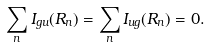<formula> <loc_0><loc_0><loc_500><loc_500>\sum _ { n } I _ { g u } ( { R } _ { n } ) = \sum _ { n } I _ { u g } ( { R } _ { n } ) = 0 .</formula> 